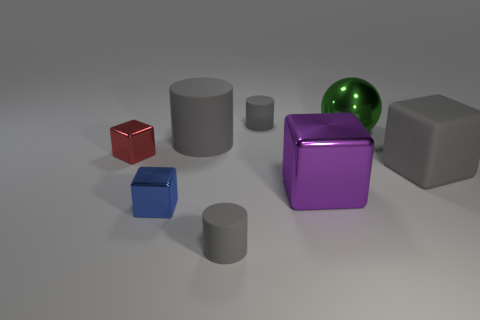What is the color of the other rubber thing that is the same shape as the purple object?
Make the answer very short. Gray. There is a small blue object behind the gray cylinder that is in front of the tiny blue thing; how many rubber objects are in front of it?
Your answer should be very brief. 1. Is there anything else that has the same material as the sphere?
Offer a terse response. Yes. Is the number of tiny blue cubes that are behind the gray matte cube less than the number of red metal cylinders?
Offer a terse response. No. Is the color of the large ball the same as the big metal cube?
Give a very brief answer. No. There is a purple thing that is the same shape as the small blue object; what size is it?
Offer a terse response. Large. What number of blue objects are the same material as the ball?
Offer a very short reply. 1. Does the small gray cylinder that is in front of the metal ball have the same material as the big ball?
Offer a very short reply. No. Are there the same number of spheres that are behind the large purple metallic block and large gray cylinders?
Provide a short and direct response. Yes. What is the size of the purple thing?
Offer a very short reply. Large. 